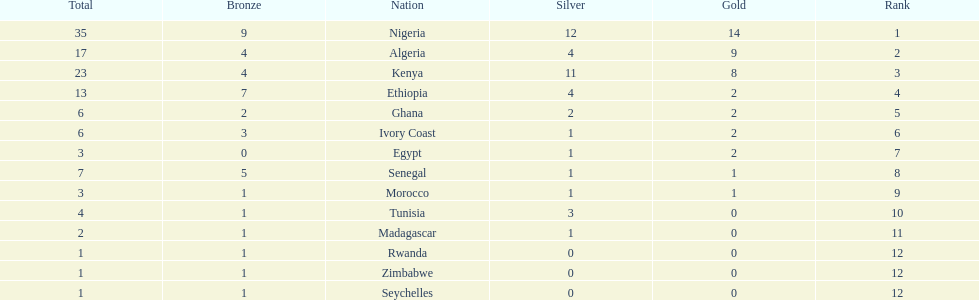Parse the table in full. {'header': ['Total', 'Bronze', 'Nation', 'Silver', 'Gold', 'Rank'], 'rows': [['35', '9', 'Nigeria', '12', '14', '1'], ['17', '4', 'Algeria', '4', '9', '2'], ['23', '4', 'Kenya', '11', '8', '3'], ['13', '7', 'Ethiopia', '4', '2', '4'], ['6', '2', 'Ghana', '2', '2', '5'], ['6', '3', 'Ivory Coast', '1', '2', '6'], ['3', '0', 'Egypt', '1', '2', '7'], ['7', '5', 'Senegal', '1', '1', '8'], ['3', '1', 'Morocco', '1', '1', '9'], ['4', '1', 'Tunisia', '3', '0', '10'], ['2', '1', 'Madagascar', '1', '0', '11'], ['1', '1', 'Rwanda', '0', '0', '12'], ['1', '1', 'Zimbabwe', '0', '0', '12'], ['1', '1', 'Seychelles', '0', '0', '12']]} On this chart, which nation appears first in the list? Nigeria. 